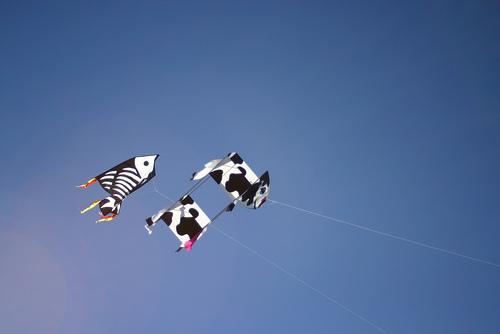What animal pattern is the two piece kite using? Please explain your reasoning. cow. That black and white blotchy pattern is often seen on bovine animals. 